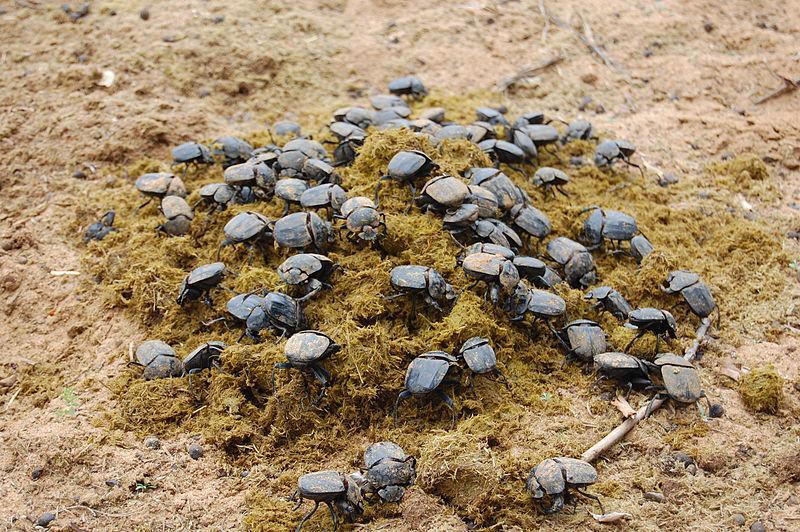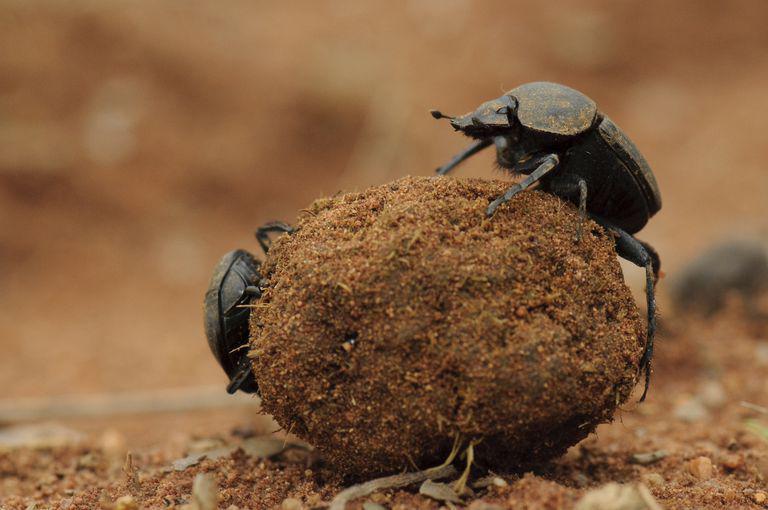The first image is the image on the left, the second image is the image on the right. Examine the images to the left and right. Is the description "An image in the pair shows exactly two beetles with a dung ball." accurate? Answer yes or no. Yes. 